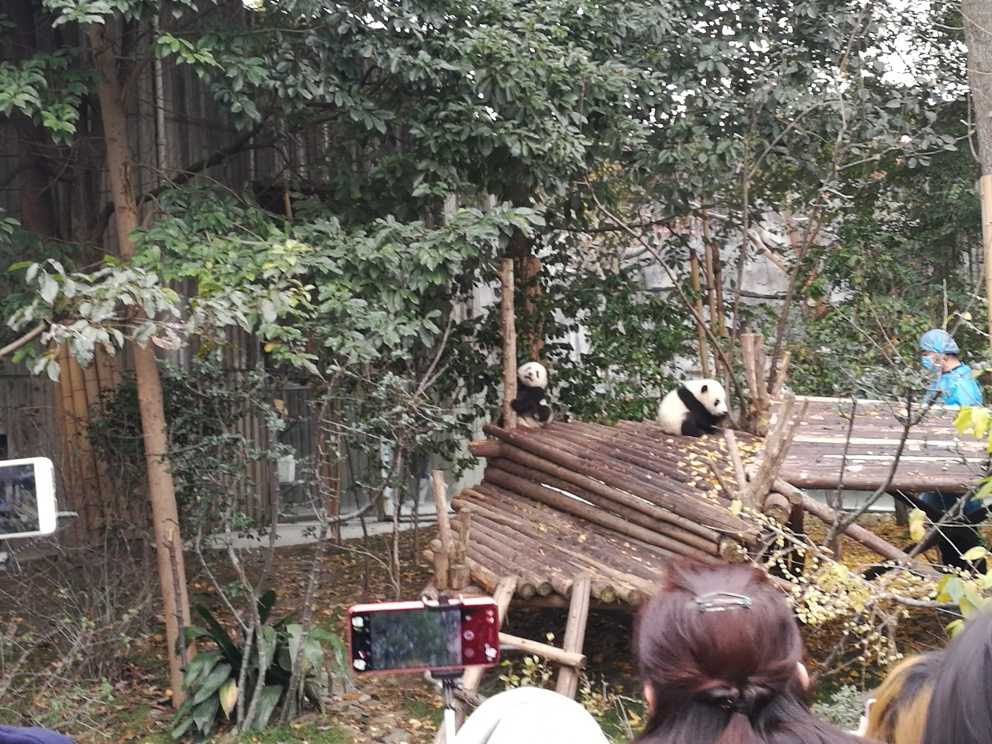Could you describe the environment where the pandas are found? Certainly! The pandas are in a contained habitat that mirrors their natural environment. There's a mix of live trees and wooden structures, likely to encourage natural climbing behavior and to provide resting platforms. The presence of a caretaker in protective clothing suggests this is a managed care facility, possibly a zoo or a conservation center dedicated to the protection and study of pandas. What's the significance of the caretaker's presence? The caretaker plays a vital role in the health and well-being of the pandas. They ensure the habitat is safe and enriching, provide food, and monitor the pandas' behavior for any signs of distress or illness. The protective clothing is important too, as it helps in maintaining a hygienic environment and prevents the transfer of potential zoonotic diseases. 